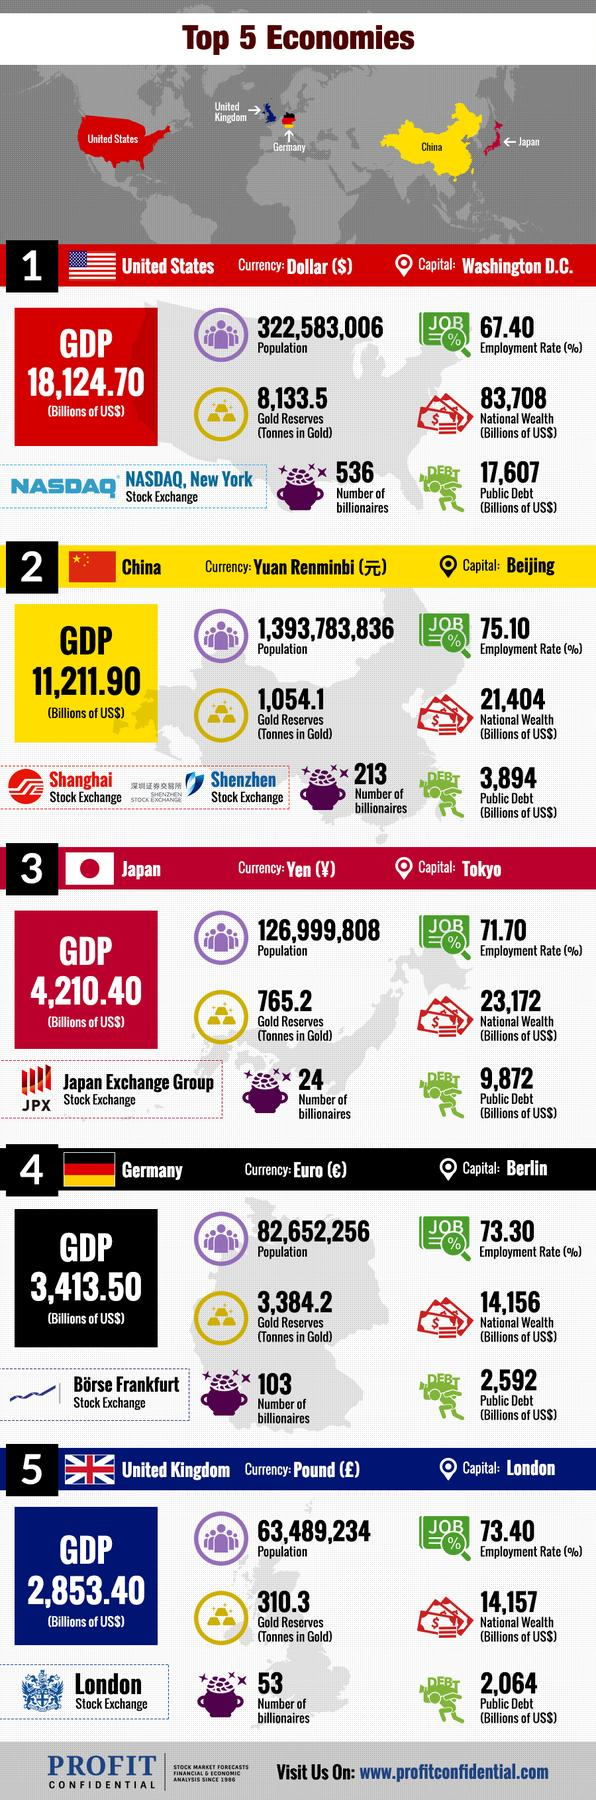Point out several critical features in this image. Japan has the lowest number of billionaires among all countries. The population of the United States is approximately 322,583,006 people. The GDP of the United States is 18,124.70. The United States has the lowest employment rate among all countries. There are 213 billionaires in China. 